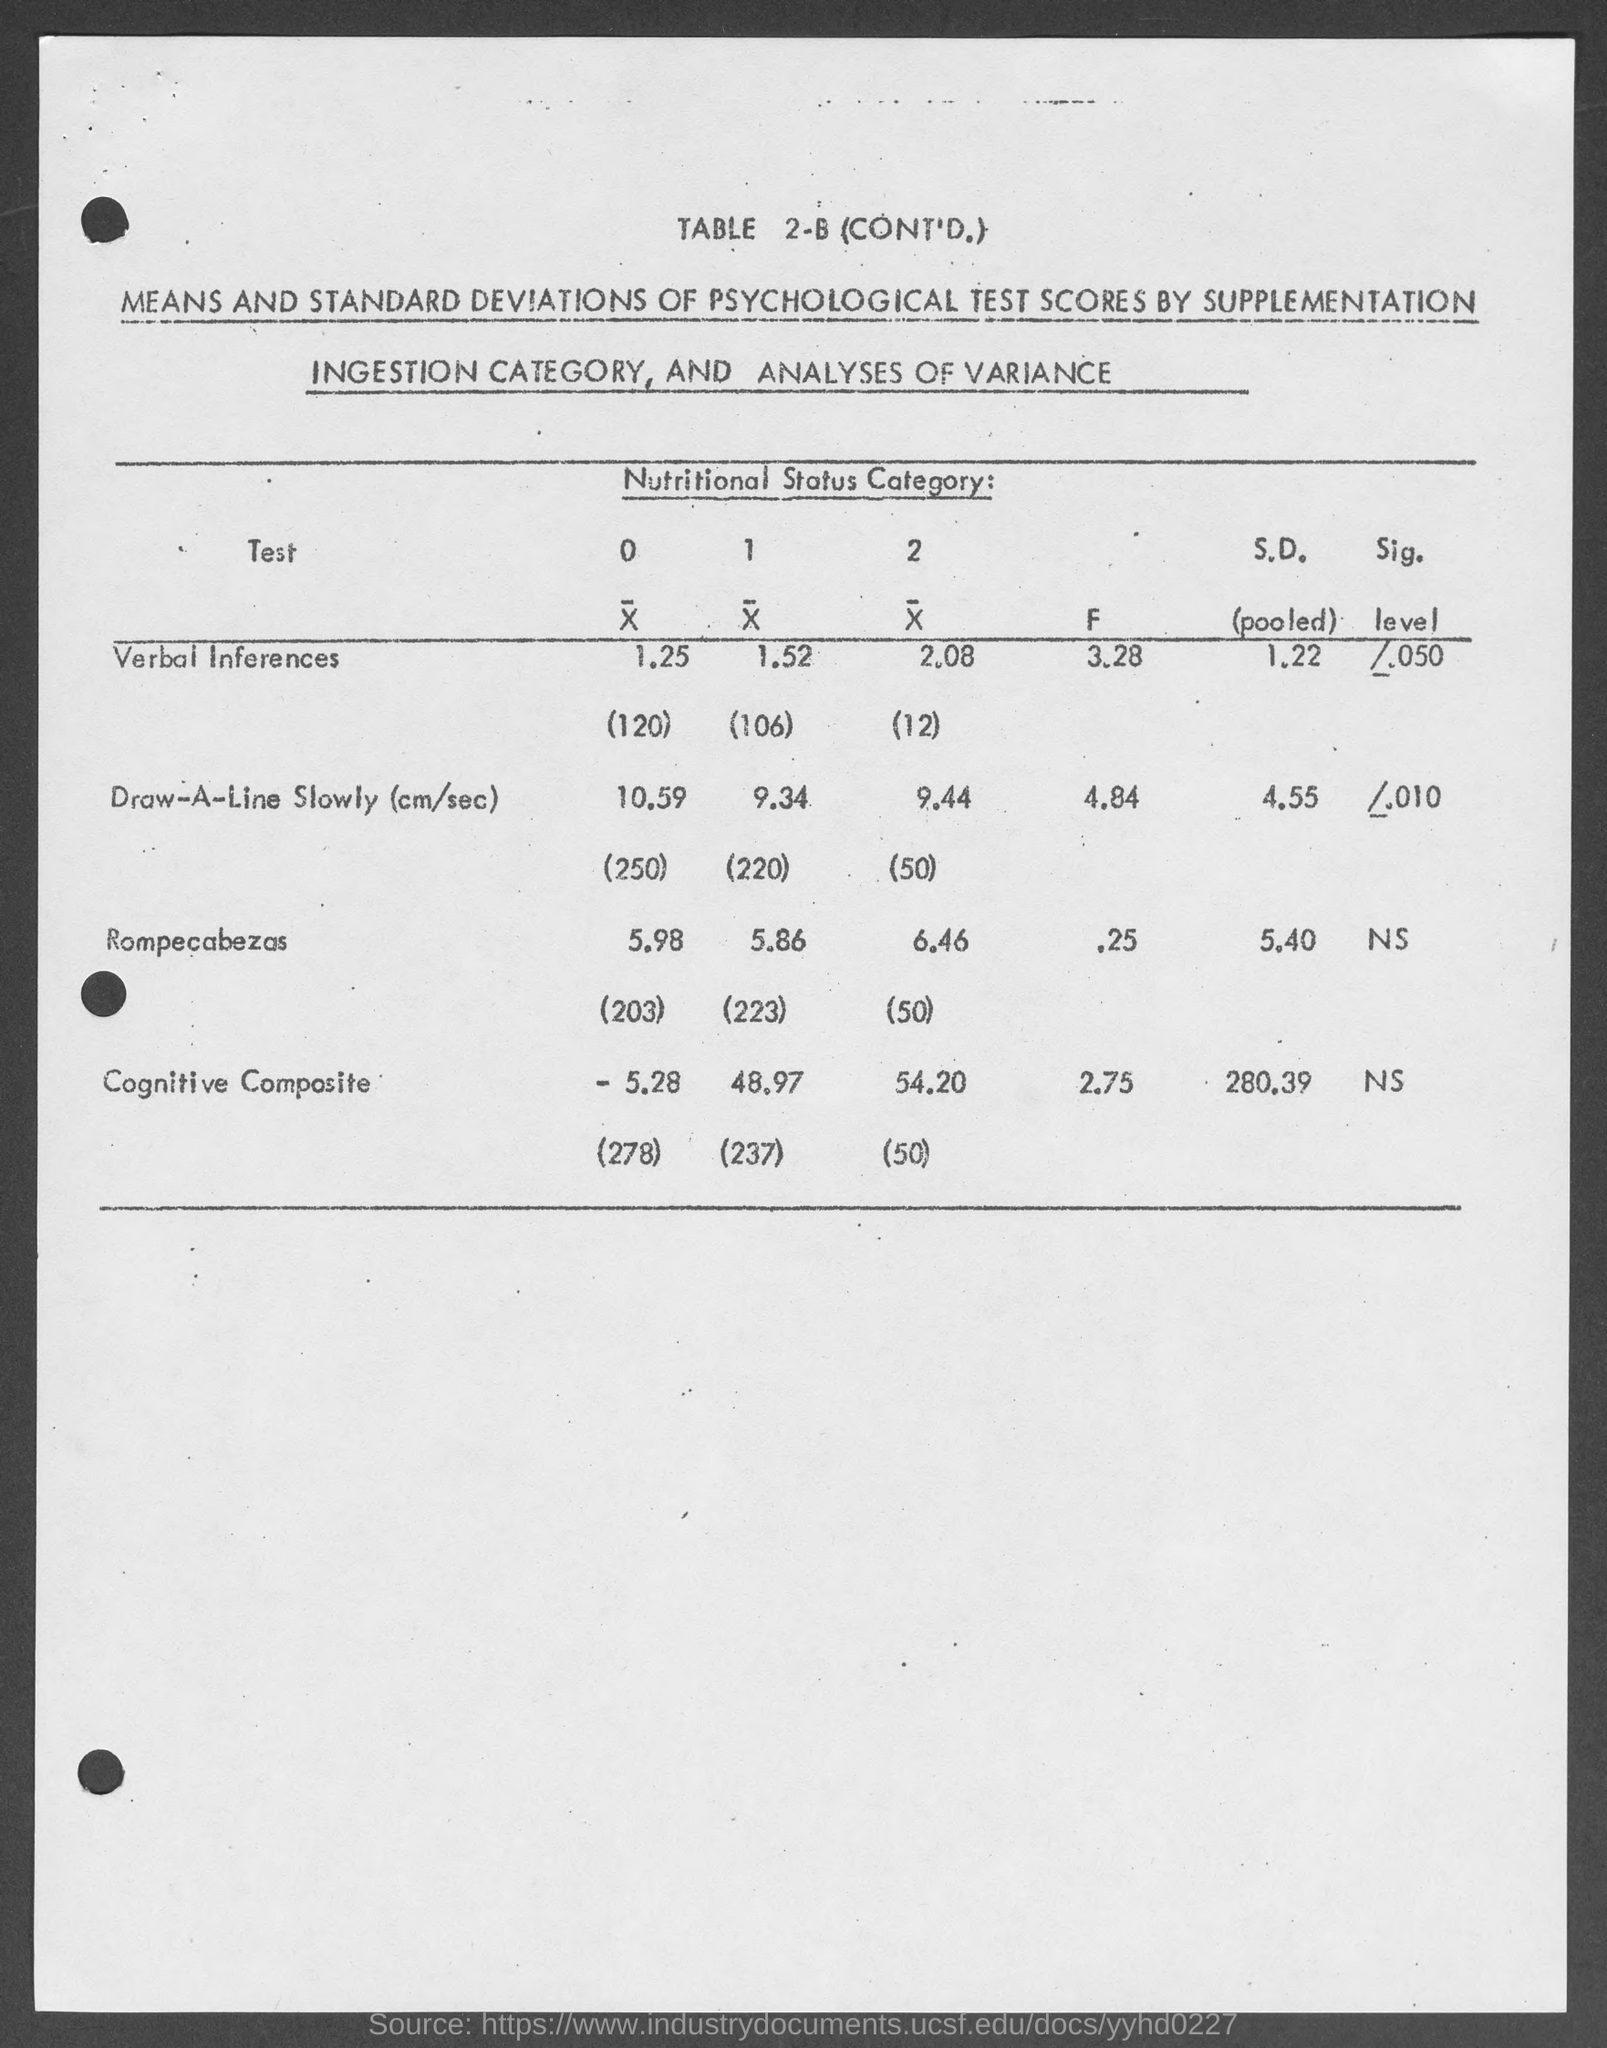Give some essential details in this illustration. The pooled standard deviation for the "Cognitive Composite" test score in TABLE 2-B is 280.39. The F value for the test "Rompecabezas" is 0.25, as per TABLE 2-B. The "F" value for the test "Verbal Inferences" is 3.28, as per TABLE 2-B. The pooled standard deviation for the "Verbal Inferences" test score is 1.22. The F value for the "Cognitive Composite" test as per TABLE 2-B is 2.75. 